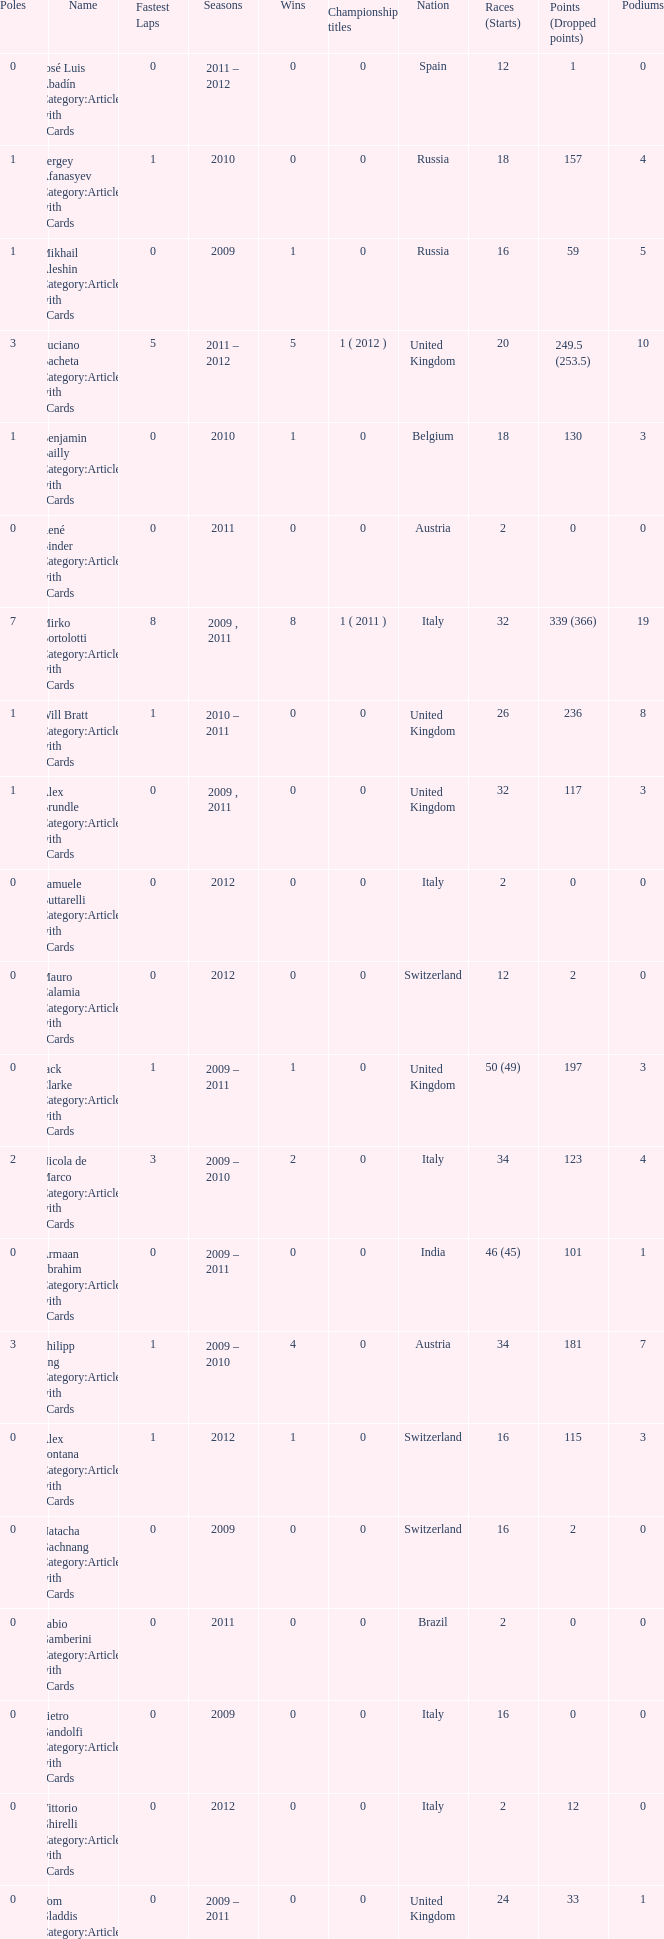What were the starts when the points dropped 18? 8.0. 